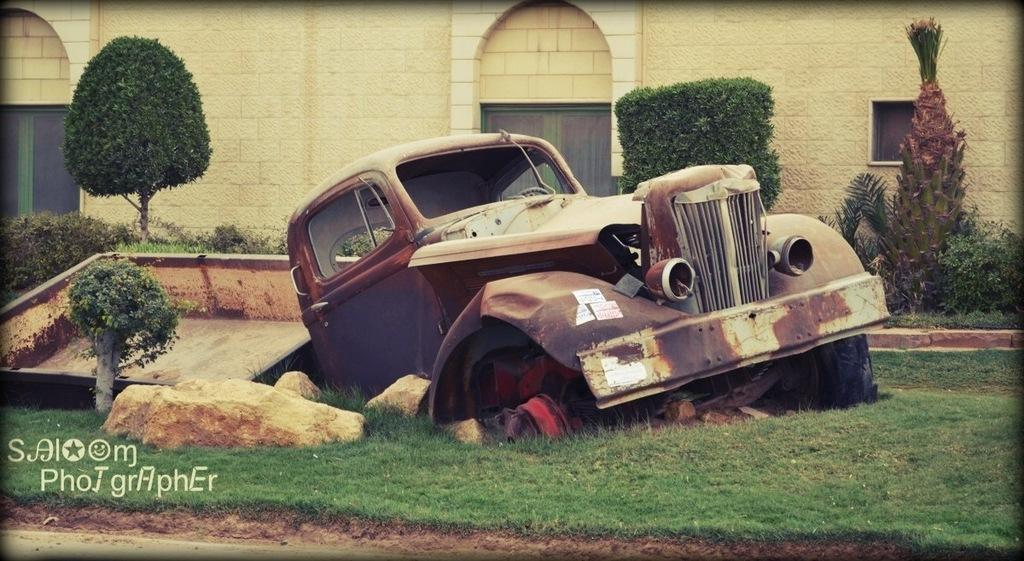What is the main subject in the center of the image? There is a truck in the center of the image. What can be seen in the background of the image? There is a wall in the background of the image. What type of vegetation is present in the image? There are plants in the image. What type of ground is visible at the bottom of the image? There is grass visible at the bottom of the image. What type of glove is being used to balance the truck in the image? There is no glove or any balancing act involving the truck in the image. 